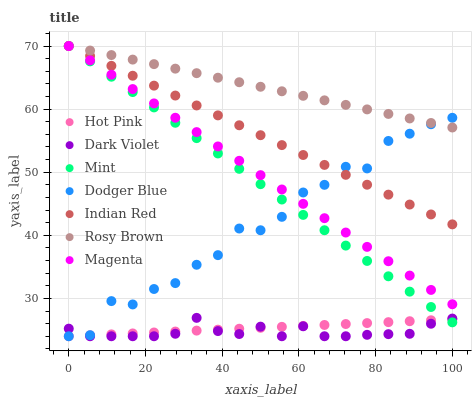Does Dark Violet have the minimum area under the curve?
Answer yes or no. Yes. Does Rosy Brown have the maximum area under the curve?
Answer yes or no. Yes. Does Rosy Brown have the minimum area under the curve?
Answer yes or no. No. Does Dark Violet have the maximum area under the curve?
Answer yes or no. No. Is Hot Pink the smoothest?
Answer yes or no. Yes. Is Dodger Blue the roughest?
Answer yes or no. Yes. Is Rosy Brown the smoothest?
Answer yes or no. No. Is Rosy Brown the roughest?
Answer yes or no. No. Does Hot Pink have the lowest value?
Answer yes or no. Yes. Does Rosy Brown have the lowest value?
Answer yes or no. No. Does Mint have the highest value?
Answer yes or no. Yes. Does Dark Violet have the highest value?
Answer yes or no. No. Is Hot Pink less than Magenta?
Answer yes or no. Yes. Is Magenta greater than Dark Violet?
Answer yes or no. Yes. Does Dark Violet intersect Mint?
Answer yes or no. Yes. Is Dark Violet less than Mint?
Answer yes or no. No. Is Dark Violet greater than Mint?
Answer yes or no. No. Does Hot Pink intersect Magenta?
Answer yes or no. No. 